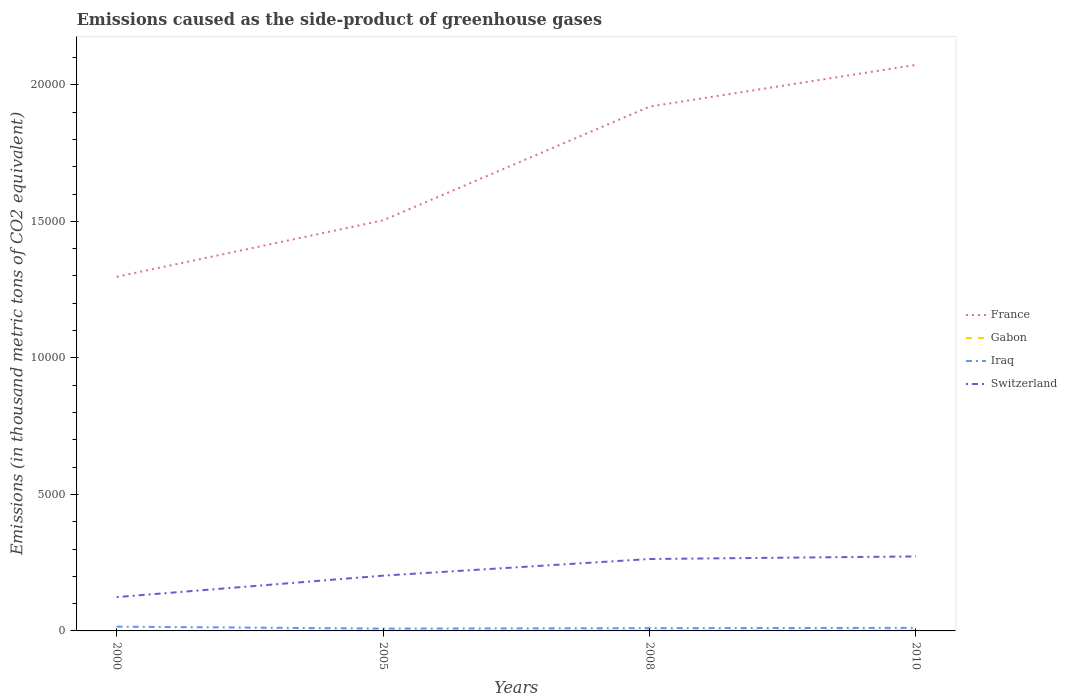Does the line corresponding to Gabon intersect with the line corresponding to Switzerland?
Offer a terse response. No. Is the number of lines equal to the number of legend labels?
Offer a terse response. Yes. Across all years, what is the maximum emissions caused as the side-product of greenhouse gases in France?
Your answer should be very brief. 1.30e+04. In which year was the emissions caused as the side-product of greenhouse gases in France maximum?
Keep it short and to the point. 2000. What is the total emissions caused as the side-product of greenhouse gases in Switzerland in the graph?
Your response must be concise. -1489.8. What is the difference between the highest and the second highest emissions caused as the side-product of greenhouse gases in Iraq?
Offer a very short reply. 70.1. How many lines are there?
Ensure brevity in your answer.  4. Are the values on the major ticks of Y-axis written in scientific E-notation?
Your answer should be very brief. No. Does the graph contain any zero values?
Your response must be concise. No. Where does the legend appear in the graph?
Provide a short and direct response. Center right. What is the title of the graph?
Your answer should be very brief. Emissions caused as the side-product of greenhouse gases. Does "Germany" appear as one of the legend labels in the graph?
Give a very brief answer. No. What is the label or title of the X-axis?
Offer a very short reply. Years. What is the label or title of the Y-axis?
Provide a short and direct response. Emissions (in thousand metric tons of CO2 equivalent). What is the Emissions (in thousand metric tons of CO2 equivalent) in France in 2000?
Keep it short and to the point. 1.30e+04. What is the Emissions (in thousand metric tons of CO2 equivalent) in Iraq in 2000?
Provide a short and direct response. 156.1. What is the Emissions (in thousand metric tons of CO2 equivalent) in Switzerland in 2000?
Provide a succinct answer. 1239.2. What is the Emissions (in thousand metric tons of CO2 equivalent) of France in 2005?
Keep it short and to the point. 1.50e+04. What is the Emissions (in thousand metric tons of CO2 equivalent) of Iraq in 2005?
Offer a very short reply. 86. What is the Emissions (in thousand metric tons of CO2 equivalent) of Switzerland in 2005?
Make the answer very short. 2025. What is the Emissions (in thousand metric tons of CO2 equivalent) in France in 2008?
Give a very brief answer. 1.92e+04. What is the Emissions (in thousand metric tons of CO2 equivalent) of Iraq in 2008?
Your answer should be compact. 101.7. What is the Emissions (in thousand metric tons of CO2 equivalent) of Switzerland in 2008?
Ensure brevity in your answer.  2634.1. What is the Emissions (in thousand metric tons of CO2 equivalent) in France in 2010?
Your answer should be compact. 2.07e+04. What is the Emissions (in thousand metric tons of CO2 equivalent) of Iraq in 2010?
Provide a short and direct response. 112. What is the Emissions (in thousand metric tons of CO2 equivalent) of Switzerland in 2010?
Offer a very short reply. 2729. Across all years, what is the maximum Emissions (in thousand metric tons of CO2 equivalent) of France?
Keep it short and to the point. 2.07e+04. Across all years, what is the maximum Emissions (in thousand metric tons of CO2 equivalent) in Gabon?
Your response must be concise. 14. Across all years, what is the maximum Emissions (in thousand metric tons of CO2 equivalent) of Iraq?
Provide a short and direct response. 156.1. Across all years, what is the maximum Emissions (in thousand metric tons of CO2 equivalent) of Switzerland?
Provide a succinct answer. 2729. Across all years, what is the minimum Emissions (in thousand metric tons of CO2 equivalent) of France?
Your answer should be compact. 1.30e+04. Across all years, what is the minimum Emissions (in thousand metric tons of CO2 equivalent) of Iraq?
Your answer should be compact. 86. Across all years, what is the minimum Emissions (in thousand metric tons of CO2 equivalent) of Switzerland?
Provide a succinct answer. 1239.2. What is the total Emissions (in thousand metric tons of CO2 equivalent) of France in the graph?
Make the answer very short. 6.79e+04. What is the total Emissions (in thousand metric tons of CO2 equivalent) in Gabon in the graph?
Ensure brevity in your answer.  37.1. What is the total Emissions (in thousand metric tons of CO2 equivalent) of Iraq in the graph?
Give a very brief answer. 455.8. What is the total Emissions (in thousand metric tons of CO2 equivalent) of Switzerland in the graph?
Your response must be concise. 8627.3. What is the difference between the Emissions (in thousand metric tons of CO2 equivalent) of France in 2000 and that in 2005?
Offer a very short reply. -2068. What is the difference between the Emissions (in thousand metric tons of CO2 equivalent) in Iraq in 2000 and that in 2005?
Offer a very short reply. 70.1. What is the difference between the Emissions (in thousand metric tons of CO2 equivalent) in Switzerland in 2000 and that in 2005?
Give a very brief answer. -785.8. What is the difference between the Emissions (in thousand metric tons of CO2 equivalent) of France in 2000 and that in 2008?
Keep it short and to the point. -6233.8. What is the difference between the Emissions (in thousand metric tons of CO2 equivalent) of Gabon in 2000 and that in 2008?
Your answer should be compact. -8.9. What is the difference between the Emissions (in thousand metric tons of CO2 equivalent) of Iraq in 2000 and that in 2008?
Your answer should be very brief. 54.4. What is the difference between the Emissions (in thousand metric tons of CO2 equivalent) in Switzerland in 2000 and that in 2008?
Offer a terse response. -1394.9. What is the difference between the Emissions (in thousand metric tons of CO2 equivalent) in France in 2000 and that in 2010?
Provide a succinct answer. -7761.8. What is the difference between the Emissions (in thousand metric tons of CO2 equivalent) in Iraq in 2000 and that in 2010?
Ensure brevity in your answer.  44.1. What is the difference between the Emissions (in thousand metric tons of CO2 equivalent) of Switzerland in 2000 and that in 2010?
Your answer should be compact. -1489.8. What is the difference between the Emissions (in thousand metric tons of CO2 equivalent) of France in 2005 and that in 2008?
Your response must be concise. -4165.8. What is the difference between the Emissions (in thousand metric tons of CO2 equivalent) in Gabon in 2005 and that in 2008?
Your answer should be compact. -3.4. What is the difference between the Emissions (in thousand metric tons of CO2 equivalent) of Iraq in 2005 and that in 2008?
Your response must be concise. -15.7. What is the difference between the Emissions (in thousand metric tons of CO2 equivalent) of Switzerland in 2005 and that in 2008?
Offer a very short reply. -609.1. What is the difference between the Emissions (in thousand metric tons of CO2 equivalent) in France in 2005 and that in 2010?
Offer a very short reply. -5693.8. What is the difference between the Emissions (in thousand metric tons of CO2 equivalent) in Gabon in 2005 and that in 2010?
Provide a short and direct response. -5.6. What is the difference between the Emissions (in thousand metric tons of CO2 equivalent) in Switzerland in 2005 and that in 2010?
Provide a short and direct response. -704. What is the difference between the Emissions (in thousand metric tons of CO2 equivalent) of France in 2008 and that in 2010?
Make the answer very short. -1528. What is the difference between the Emissions (in thousand metric tons of CO2 equivalent) in Gabon in 2008 and that in 2010?
Provide a short and direct response. -2.2. What is the difference between the Emissions (in thousand metric tons of CO2 equivalent) of Iraq in 2008 and that in 2010?
Offer a terse response. -10.3. What is the difference between the Emissions (in thousand metric tons of CO2 equivalent) in Switzerland in 2008 and that in 2010?
Offer a terse response. -94.9. What is the difference between the Emissions (in thousand metric tons of CO2 equivalent) in France in 2000 and the Emissions (in thousand metric tons of CO2 equivalent) in Gabon in 2005?
Provide a short and direct response. 1.30e+04. What is the difference between the Emissions (in thousand metric tons of CO2 equivalent) of France in 2000 and the Emissions (in thousand metric tons of CO2 equivalent) of Iraq in 2005?
Give a very brief answer. 1.29e+04. What is the difference between the Emissions (in thousand metric tons of CO2 equivalent) of France in 2000 and the Emissions (in thousand metric tons of CO2 equivalent) of Switzerland in 2005?
Provide a succinct answer. 1.09e+04. What is the difference between the Emissions (in thousand metric tons of CO2 equivalent) in Gabon in 2000 and the Emissions (in thousand metric tons of CO2 equivalent) in Iraq in 2005?
Make the answer very short. -83.1. What is the difference between the Emissions (in thousand metric tons of CO2 equivalent) in Gabon in 2000 and the Emissions (in thousand metric tons of CO2 equivalent) in Switzerland in 2005?
Your answer should be very brief. -2022.1. What is the difference between the Emissions (in thousand metric tons of CO2 equivalent) of Iraq in 2000 and the Emissions (in thousand metric tons of CO2 equivalent) of Switzerland in 2005?
Offer a very short reply. -1868.9. What is the difference between the Emissions (in thousand metric tons of CO2 equivalent) of France in 2000 and the Emissions (in thousand metric tons of CO2 equivalent) of Gabon in 2008?
Make the answer very short. 1.30e+04. What is the difference between the Emissions (in thousand metric tons of CO2 equivalent) in France in 2000 and the Emissions (in thousand metric tons of CO2 equivalent) in Iraq in 2008?
Keep it short and to the point. 1.29e+04. What is the difference between the Emissions (in thousand metric tons of CO2 equivalent) of France in 2000 and the Emissions (in thousand metric tons of CO2 equivalent) of Switzerland in 2008?
Provide a succinct answer. 1.03e+04. What is the difference between the Emissions (in thousand metric tons of CO2 equivalent) of Gabon in 2000 and the Emissions (in thousand metric tons of CO2 equivalent) of Iraq in 2008?
Offer a very short reply. -98.8. What is the difference between the Emissions (in thousand metric tons of CO2 equivalent) in Gabon in 2000 and the Emissions (in thousand metric tons of CO2 equivalent) in Switzerland in 2008?
Offer a terse response. -2631.2. What is the difference between the Emissions (in thousand metric tons of CO2 equivalent) in Iraq in 2000 and the Emissions (in thousand metric tons of CO2 equivalent) in Switzerland in 2008?
Provide a short and direct response. -2478. What is the difference between the Emissions (in thousand metric tons of CO2 equivalent) in France in 2000 and the Emissions (in thousand metric tons of CO2 equivalent) in Gabon in 2010?
Offer a terse response. 1.30e+04. What is the difference between the Emissions (in thousand metric tons of CO2 equivalent) of France in 2000 and the Emissions (in thousand metric tons of CO2 equivalent) of Iraq in 2010?
Offer a terse response. 1.29e+04. What is the difference between the Emissions (in thousand metric tons of CO2 equivalent) of France in 2000 and the Emissions (in thousand metric tons of CO2 equivalent) of Switzerland in 2010?
Offer a very short reply. 1.02e+04. What is the difference between the Emissions (in thousand metric tons of CO2 equivalent) in Gabon in 2000 and the Emissions (in thousand metric tons of CO2 equivalent) in Iraq in 2010?
Make the answer very short. -109.1. What is the difference between the Emissions (in thousand metric tons of CO2 equivalent) of Gabon in 2000 and the Emissions (in thousand metric tons of CO2 equivalent) of Switzerland in 2010?
Give a very brief answer. -2726.1. What is the difference between the Emissions (in thousand metric tons of CO2 equivalent) in Iraq in 2000 and the Emissions (in thousand metric tons of CO2 equivalent) in Switzerland in 2010?
Make the answer very short. -2572.9. What is the difference between the Emissions (in thousand metric tons of CO2 equivalent) in France in 2005 and the Emissions (in thousand metric tons of CO2 equivalent) in Gabon in 2008?
Offer a terse response. 1.50e+04. What is the difference between the Emissions (in thousand metric tons of CO2 equivalent) in France in 2005 and the Emissions (in thousand metric tons of CO2 equivalent) in Iraq in 2008?
Provide a short and direct response. 1.49e+04. What is the difference between the Emissions (in thousand metric tons of CO2 equivalent) of France in 2005 and the Emissions (in thousand metric tons of CO2 equivalent) of Switzerland in 2008?
Provide a succinct answer. 1.24e+04. What is the difference between the Emissions (in thousand metric tons of CO2 equivalent) in Gabon in 2005 and the Emissions (in thousand metric tons of CO2 equivalent) in Iraq in 2008?
Offer a very short reply. -93.3. What is the difference between the Emissions (in thousand metric tons of CO2 equivalent) in Gabon in 2005 and the Emissions (in thousand metric tons of CO2 equivalent) in Switzerland in 2008?
Your response must be concise. -2625.7. What is the difference between the Emissions (in thousand metric tons of CO2 equivalent) of Iraq in 2005 and the Emissions (in thousand metric tons of CO2 equivalent) of Switzerland in 2008?
Ensure brevity in your answer.  -2548.1. What is the difference between the Emissions (in thousand metric tons of CO2 equivalent) of France in 2005 and the Emissions (in thousand metric tons of CO2 equivalent) of Gabon in 2010?
Provide a succinct answer. 1.50e+04. What is the difference between the Emissions (in thousand metric tons of CO2 equivalent) of France in 2005 and the Emissions (in thousand metric tons of CO2 equivalent) of Iraq in 2010?
Provide a succinct answer. 1.49e+04. What is the difference between the Emissions (in thousand metric tons of CO2 equivalent) of France in 2005 and the Emissions (in thousand metric tons of CO2 equivalent) of Switzerland in 2010?
Make the answer very short. 1.23e+04. What is the difference between the Emissions (in thousand metric tons of CO2 equivalent) of Gabon in 2005 and the Emissions (in thousand metric tons of CO2 equivalent) of Iraq in 2010?
Provide a short and direct response. -103.6. What is the difference between the Emissions (in thousand metric tons of CO2 equivalent) of Gabon in 2005 and the Emissions (in thousand metric tons of CO2 equivalent) of Switzerland in 2010?
Keep it short and to the point. -2720.6. What is the difference between the Emissions (in thousand metric tons of CO2 equivalent) in Iraq in 2005 and the Emissions (in thousand metric tons of CO2 equivalent) in Switzerland in 2010?
Give a very brief answer. -2643. What is the difference between the Emissions (in thousand metric tons of CO2 equivalent) in France in 2008 and the Emissions (in thousand metric tons of CO2 equivalent) in Gabon in 2010?
Ensure brevity in your answer.  1.92e+04. What is the difference between the Emissions (in thousand metric tons of CO2 equivalent) in France in 2008 and the Emissions (in thousand metric tons of CO2 equivalent) in Iraq in 2010?
Your answer should be compact. 1.91e+04. What is the difference between the Emissions (in thousand metric tons of CO2 equivalent) of France in 2008 and the Emissions (in thousand metric tons of CO2 equivalent) of Switzerland in 2010?
Ensure brevity in your answer.  1.65e+04. What is the difference between the Emissions (in thousand metric tons of CO2 equivalent) in Gabon in 2008 and the Emissions (in thousand metric tons of CO2 equivalent) in Iraq in 2010?
Your response must be concise. -100.2. What is the difference between the Emissions (in thousand metric tons of CO2 equivalent) of Gabon in 2008 and the Emissions (in thousand metric tons of CO2 equivalent) of Switzerland in 2010?
Provide a short and direct response. -2717.2. What is the difference between the Emissions (in thousand metric tons of CO2 equivalent) in Iraq in 2008 and the Emissions (in thousand metric tons of CO2 equivalent) in Switzerland in 2010?
Ensure brevity in your answer.  -2627.3. What is the average Emissions (in thousand metric tons of CO2 equivalent) of France per year?
Your answer should be compact. 1.70e+04. What is the average Emissions (in thousand metric tons of CO2 equivalent) in Gabon per year?
Keep it short and to the point. 9.28. What is the average Emissions (in thousand metric tons of CO2 equivalent) of Iraq per year?
Your response must be concise. 113.95. What is the average Emissions (in thousand metric tons of CO2 equivalent) in Switzerland per year?
Ensure brevity in your answer.  2156.82. In the year 2000, what is the difference between the Emissions (in thousand metric tons of CO2 equivalent) of France and Emissions (in thousand metric tons of CO2 equivalent) of Gabon?
Offer a terse response. 1.30e+04. In the year 2000, what is the difference between the Emissions (in thousand metric tons of CO2 equivalent) in France and Emissions (in thousand metric tons of CO2 equivalent) in Iraq?
Your answer should be very brief. 1.28e+04. In the year 2000, what is the difference between the Emissions (in thousand metric tons of CO2 equivalent) in France and Emissions (in thousand metric tons of CO2 equivalent) in Switzerland?
Provide a short and direct response. 1.17e+04. In the year 2000, what is the difference between the Emissions (in thousand metric tons of CO2 equivalent) in Gabon and Emissions (in thousand metric tons of CO2 equivalent) in Iraq?
Give a very brief answer. -153.2. In the year 2000, what is the difference between the Emissions (in thousand metric tons of CO2 equivalent) of Gabon and Emissions (in thousand metric tons of CO2 equivalent) of Switzerland?
Your answer should be very brief. -1236.3. In the year 2000, what is the difference between the Emissions (in thousand metric tons of CO2 equivalent) of Iraq and Emissions (in thousand metric tons of CO2 equivalent) of Switzerland?
Ensure brevity in your answer.  -1083.1. In the year 2005, what is the difference between the Emissions (in thousand metric tons of CO2 equivalent) of France and Emissions (in thousand metric tons of CO2 equivalent) of Gabon?
Provide a short and direct response. 1.50e+04. In the year 2005, what is the difference between the Emissions (in thousand metric tons of CO2 equivalent) in France and Emissions (in thousand metric tons of CO2 equivalent) in Iraq?
Keep it short and to the point. 1.50e+04. In the year 2005, what is the difference between the Emissions (in thousand metric tons of CO2 equivalent) in France and Emissions (in thousand metric tons of CO2 equivalent) in Switzerland?
Your answer should be compact. 1.30e+04. In the year 2005, what is the difference between the Emissions (in thousand metric tons of CO2 equivalent) in Gabon and Emissions (in thousand metric tons of CO2 equivalent) in Iraq?
Provide a succinct answer. -77.6. In the year 2005, what is the difference between the Emissions (in thousand metric tons of CO2 equivalent) in Gabon and Emissions (in thousand metric tons of CO2 equivalent) in Switzerland?
Make the answer very short. -2016.6. In the year 2005, what is the difference between the Emissions (in thousand metric tons of CO2 equivalent) of Iraq and Emissions (in thousand metric tons of CO2 equivalent) of Switzerland?
Your answer should be compact. -1939. In the year 2008, what is the difference between the Emissions (in thousand metric tons of CO2 equivalent) of France and Emissions (in thousand metric tons of CO2 equivalent) of Gabon?
Ensure brevity in your answer.  1.92e+04. In the year 2008, what is the difference between the Emissions (in thousand metric tons of CO2 equivalent) in France and Emissions (in thousand metric tons of CO2 equivalent) in Iraq?
Provide a short and direct response. 1.91e+04. In the year 2008, what is the difference between the Emissions (in thousand metric tons of CO2 equivalent) of France and Emissions (in thousand metric tons of CO2 equivalent) of Switzerland?
Your answer should be compact. 1.66e+04. In the year 2008, what is the difference between the Emissions (in thousand metric tons of CO2 equivalent) of Gabon and Emissions (in thousand metric tons of CO2 equivalent) of Iraq?
Ensure brevity in your answer.  -89.9. In the year 2008, what is the difference between the Emissions (in thousand metric tons of CO2 equivalent) of Gabon and Emissions (in thousand metric tons of CO2 equivalent) of Switzerland?
Ensure brevity in your answer.  -2622.3. In the year 2008, what is the difference between the Emissions (in thousand metric tons of CO2 equivalent) in Iraq and Emissions (in thousand metric tons of CO2 equivalent) in Switzerland?
Offer a very short reply. -2532.4. In the year 2010, what is the difference between the Emissions (in thousand metric tons of CO2 equivalent) of France and Emissions (in thousand metric tons of CO2 equivalent) of Gabon?
Make the answer very short. 2.07e+04. In the year 2010, what is the difference between the Emissions (in thousand metric tons of CO2 equivalent) of France and Emissions (in thousand metric tons of CO2 equivalent) of Iraq?
Provide a succinct answer. 2.06e+04. In the year 2010, what is the difference between the Emissions (in thousand metric tons of CO2 equivalent) in France and Emissions (in thousand metric tons of CO2 equivalent) in Switzerland?
Offer a very short reply. 1.80e+04. In the year 2010, what is the difference between the Emissions (in thousand metric tons of CO2 equivalent) of Gabon and Emissions (in thousand metric tons of CO2 equivalent) of Iraq?
Give a very brief answer. -98. In the year 2010, what is the difference between the Emissions (in thousand metric tons of CO2 equivalent) of Gabon and Emissions (in thousand metric tons of CO2 equivalent) of Switzerland?
Your answer should be very brief. -2715. In the year 2010, what is the difference between the Emissions (in thousand metric tons of CO2 equivalent) in Iraq and Emissions (in thousand metric tons of CO2 equivalent) in Switzerland?
Give a very brief answer. -2617. What is the ratio of the Emissions (in thousand metric tons of CO2 equivalent) of France in 2000 to that in 2005?
Ensure brevity in your answer.  0.86. What is the ratio of the Emissions (in thousand metric tons of CO2 equivalent) in Gabon in 2000 to that in 2005?
Your answer should be very brief. 0.35. What is the ratio of the Emissions (in thousand metric tons of CO2 equivalent) of Iraq in 2000 to that in 2005?
Provide a succinct answer. 1.82. What is the ratio of the Emissions (in thousand metric tons of CO2 equivalent) of Switzerland in 2000 to that in 2005?
Your answer should be compact. 0.61. What is the ratio of the Emissions (in thousand metric tons of CO2 equivalent) in France in 2000 to that in 2008?
Provide a short and direct response. 0.68. What is the ratio of the Emissions (in thousand metric tons of CO2 equivalent) in Gabon in 2000 to that in 2008?
Your answer should be very brief. 0.25. What is the ratio of the Emissions (in thousand metric tons of CO2 equivalent) in Iraq in 2000 to that in 2008?
Keep it short and to the point. 1.53. What is the ratio of the Emissions (in thousand metric tons of CO2 equivalent) of Switzerland in 2000 to that in 2008?
Keep it short and to the point. 0.47. What is the ratio of the Emissions (in thousand metric tons of CO2 equivalent) of France in 2000 to that in 2010?
Keep it short and to the point. 0.63. What is the ratio of the Emissions (in thousand metric tons of CO2 equivalent) of Gabon in 2000 to that in 2010?
Ensure brevity in your answer.  0.21. What is the ratio of the Emissions (in thousand metric tons of CO2 equivalent) in Iraq in 2000 to that in 2010?
Your response must be concise. 1.39. What is the ratio of the Emissions (in thousand metric tons of CO2 equivalent) of Switzerland in 2000 to that in 2010?
Your answer should be compact. 0.45. What is the ratio of the Emissions (in thousand metric tons of CO2 equivalent) of France in 2005 to that in 2008?
Keep it short and to the point. 0.78. What is the ratio of the Emissions (in thousand metric tons of CO2 equivalent) of Gabon in 2005 to that in 2008?
Give a very brief answer. 0.71. What is the ratio of the Emissions (in thousand metric tons of CO2 equivalent) in Iraq in 2005 to that in 2008?
Make the answer very short. 0.85. What is the ratio of the Emissions (in thousand metric tons of CO2 equivalent) of Switzerland in 2005 to that in 2008?
Provide a short and direct response. 0.77. What is the ratio of the Emissions (in thousand metric tons of CO2 equivalent) of France in 2005 to that in 2010?
Offer a terse response. 0.73. What is the ratio of the Emissions (in thousand metric tons of CO2 equivalent) in Iraq in 2005 to that in 2010?
Make the answer very short. 0.77. What is the ratio of the Emissions (in thousand metric tons of CO2 equivalent) of Switzerland in 2005 to that in 2010?
Your response must be concise. 0.74. What is the ratio of the Emissions (in thousand metric tons of CO2 equivalent) of France in 2008 to that in 2010?
Offer a very short reply. 0.93. What is the ratio of the Emissions (in thousand metric tons of CO2 equivalent) of Gabon in 2008 to that in 2010?
Your response must be concise. 0.84. What is the ratio of the Emissions (in thousand metric tons of CO2 equivalent) of Iraq in 2008 to that in 2010?
Provide a short and direct response. 0.91. What is the ratio of the Emissions (in thousand metric tons of CO2 equivalent) in Switzerland in 2008 to that in 2010?
Your answer should be very brief. 0.97. What is the difference between the highest and the second highest Emissions (in thousand metric tons of CO2 equivalent) of France?
Ensure brevity in your answer.  1528. What is the difference between the highest and the second highest Emissions (in thousand metric tons of CO2 equivalent) in Iraq?
Your answer should be very brief. 44.1. What is the difference between the highest and the second highest Emissions (in thousand metric tons of CO2 equivalent) in Switzerland?
Provide a succinct answer. 94.9. What is the difference between the highest and the lowest Emissions (in thousand metric tons of CO2 equivalent) in France?
Make the answer very short. 7761.8. What is the difference between the highest and the lowest Emissions (in thousand metric tons of CO2 equivalent) in Gabon?
Your response must be concise. 11.1. What is the difference between the highest and the lowest Emissions (in thousand metric tons of CO2 equivalent) of Iraq?
Provide a short and direct response. 70.1. What is the difference between the highest and the lowest Emissions (in thousand metric tons of CO2 equivalent) in Switzerland?
Offer a very short reply. 1489.8. 